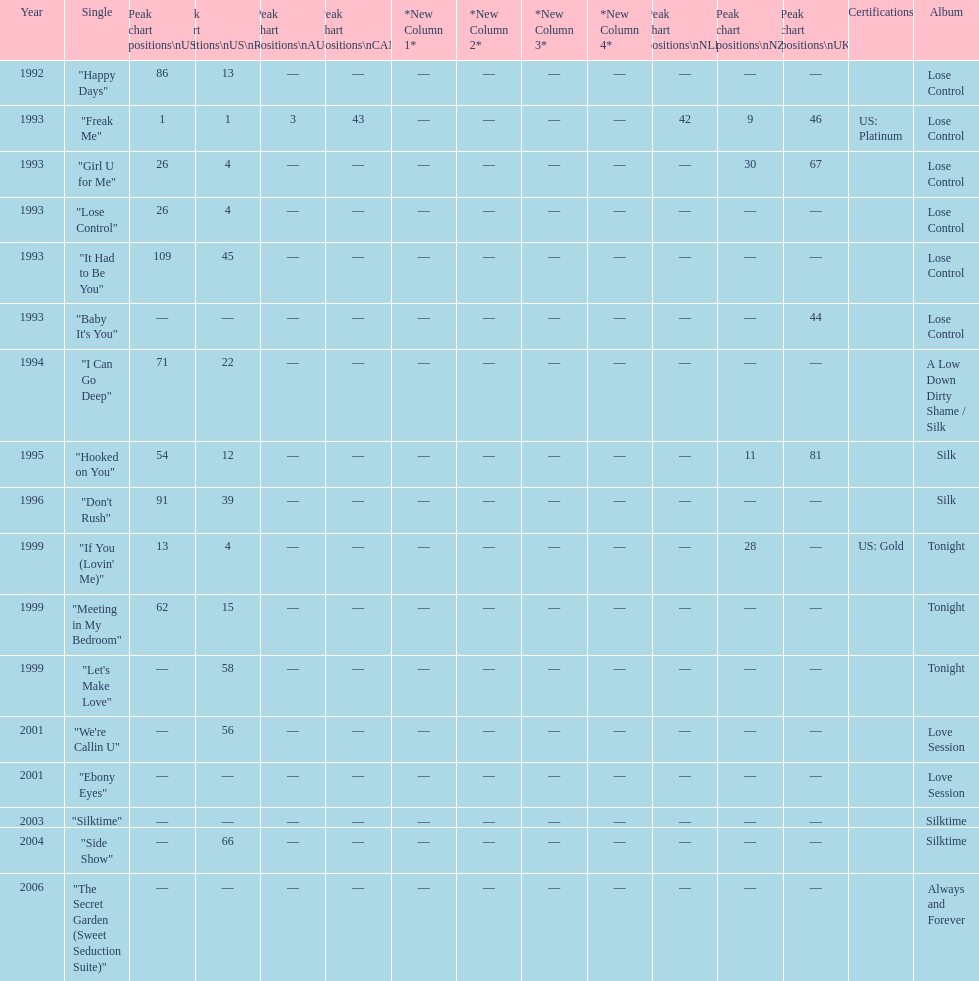Compare "i can go deep" with "don't rush". which was higher on the us and us r&b charts? "I Can Go Deep". 